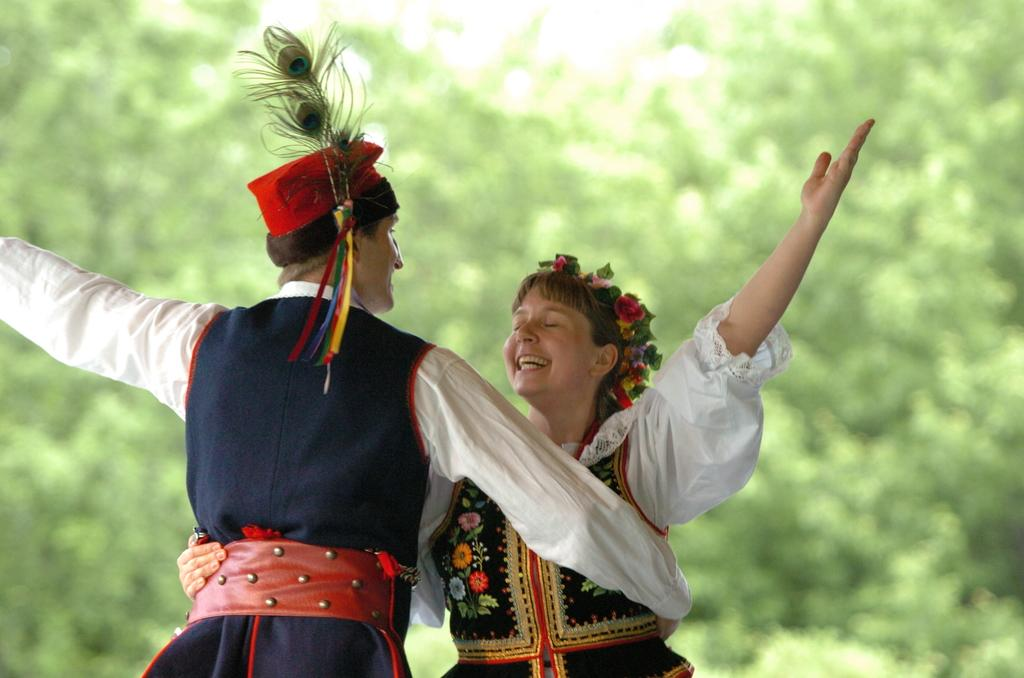How many people are in the image? There are two people in the image. What are the people doing in the image? The people are dancing on a path. What is the emotional expression of the people in the image? The people are smiling. What can be seen in the background of the image? There are trees visible in the background of the image. What type of hammer can be seen being used by the people in the image? There is no hammer present in the image; the people are dancing on a path. 